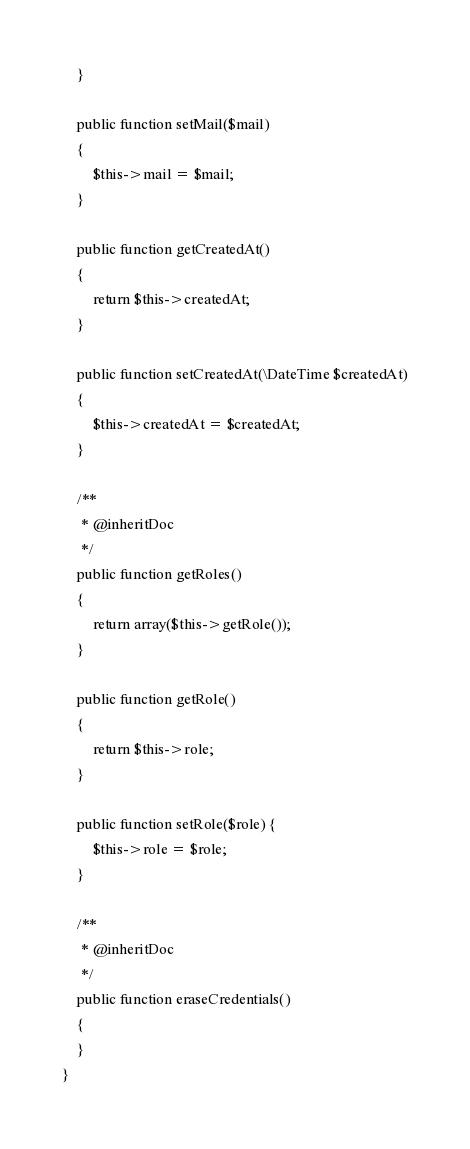<code> <loc_0><loc_0><loc_500><loc_500><_PHP_>    }

    public function setMail($mail)
    {
        $this->mail = $mail;
    }

    public function getCreatedAt()
    {
        return $this->createdAt;
    }

    public function setCreatedAt(\DateTime $createdAt)
    {
        $this->createdAt = $createdAt;
    }

    /**
     * @inheritDoc
     */
    public function getRoles()
    {
        return array($this->getRole());
    }

    public function getRole()
    {
        return $this->role;
    }

    public function setRole($role) {
        $this->role = $role;
    }

    /**
     * @inheritDoc
     */
    public function eraseCredentials()
    {
    }
}
</code> 